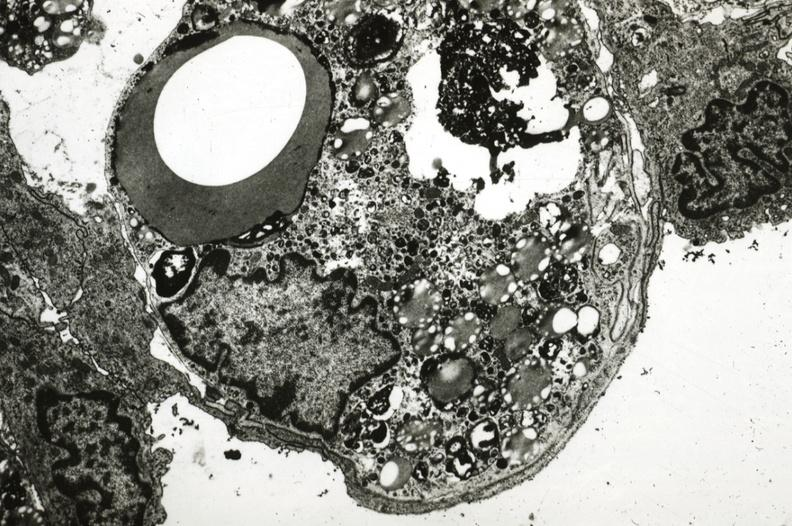s aorta present?
Answer the question using a single word or phrase. Yes 